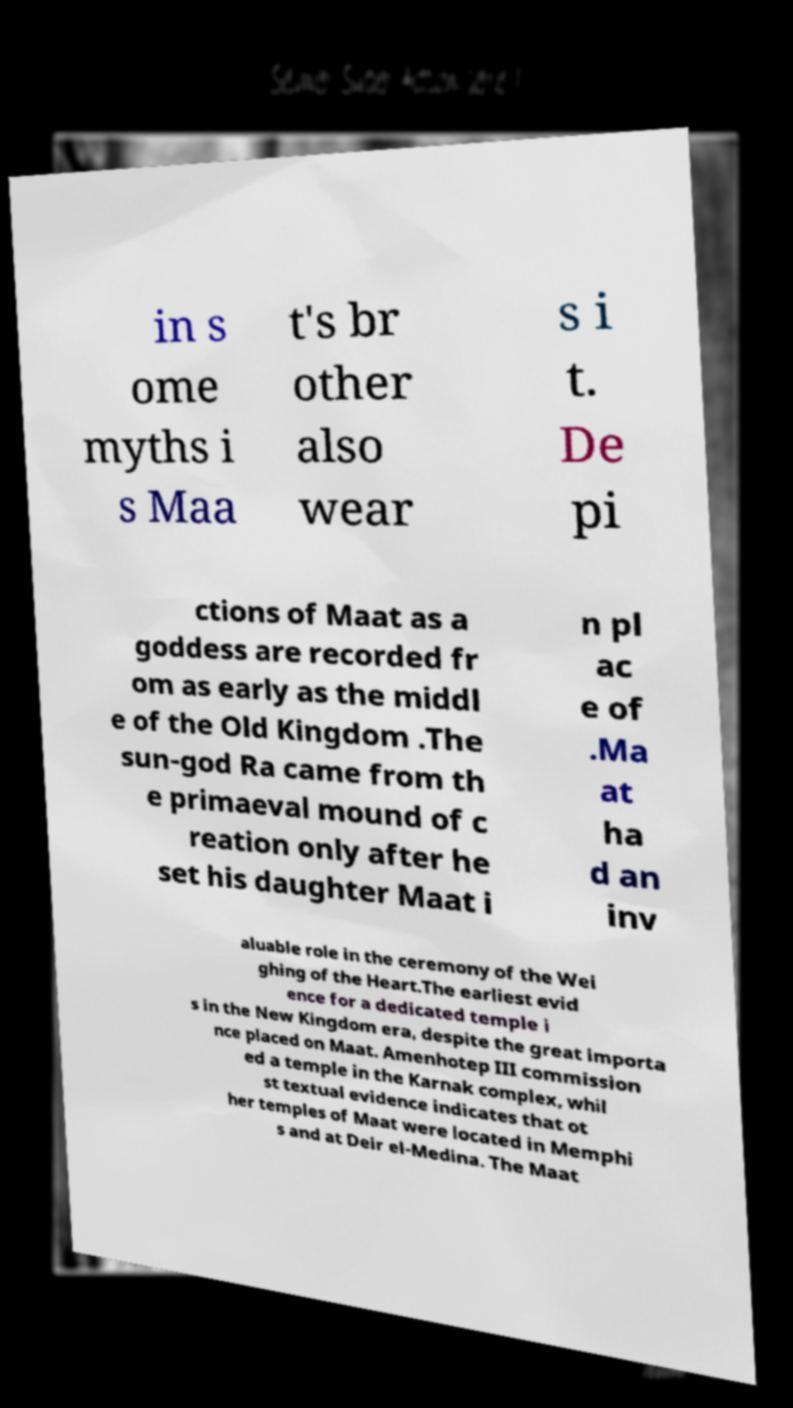Could you extract and type out the text from this image? in s ome myths i s Maa t's br other also wear s i t. De pi ctions of Maat as a goddess are recorded fr om as early as the middl e of the Old Kingdom .The sun-god Ra came from th e primaeval mound of c reation only after he set his daughter Maat i n pl ac e of .Ma at ha d an inv aluable role in the ceremony of the Wei ghing of the Heart.The earliest evid ence for a dedicated temple i s in the New Kingdom era, despite the great importa nce placed on Maat. Amenhotep III commission ed a temple in the Karnak complex, whil st textual evidence indicates that ot her temples of Maat were located in Memphi s and at Deir el-Medina. The Maat 